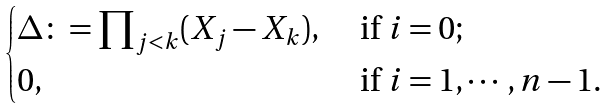<formula> <loc_0><loc_0><loc_500><loc_500>\begin{cases} \Delta \colon = \prod _ { j < k } ( X _ { j } - X _ { k } ) , & \text { if $i=0$;} \\ 0 , & \text { if $i=1,\cdots,n-1$.} \end{cases}</formula> 